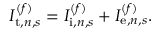<formula> <loc_0><loc_0><loc_500><loc_500>I _ { t , n , s } ^ { ( f ) } = I _ { i , n , s } ^ { ( f ) } + I _ { e , n , s } ^ { ( f ) } .</formula> 